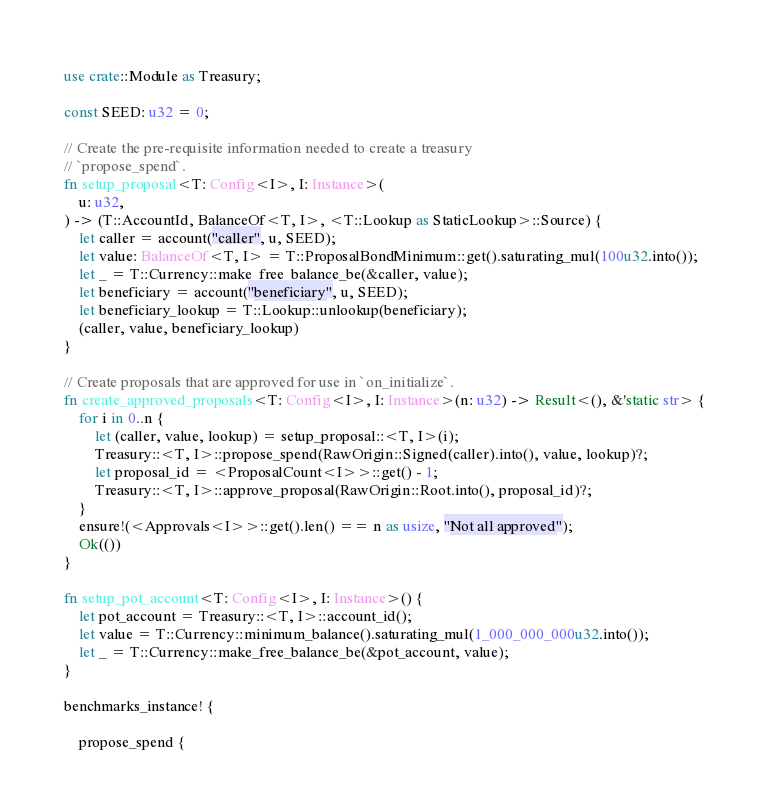Convert code to text. <code><loc_0><loc_0><loc_500><loc_500><_Rust_>
use crate::Module as Treasury;

const SEED: u32 = 0;

// Create the pre-requisite information needed to create a treasury
// `propose_spend`.
fn setup_proposal<T: Config<I>, I: Instance>(
	u: u32,
) -> (T::AccountId, BalanceOf<T, I>, <T::Lookup as StaticLookup>::Source) {
	let caller = account("caller", u, SEED);
	let value: BalanceOf<T, I> = T::ProposalBondMinimum::get().saturating_mul(100u32.into());
	let _ = T::Currency::make_free_balance_be(&caller, value);
	let beneficiary = account("beneficiary", u, SEED);
	let beneficiary_lookup = T::Lookup::unlookup(beneficiary);
	(caller, value, beneficiary_lookup)
}

// Create proposals that are approved for use in `on_initialize`.
fn create_approved_proposals<T: Config<I>, I: Instance>(n: u32) -> Result<(), &'static str> {
	for i in 0..n {
		let (caller, value, lookup) = setup_proposal::<T, I>(i);
		Treasury::<T, I>::propose_spend(RawOrigin::Signed(caller).into(), value, lookup)?;
		let proposal_id = <ProposalCount<I>>::get() - 1;
		Treasury::<T, I>::approve_proposal(RawOrigin::Root.into(), proposal_id)?;
	}
	ensure!(<Approvals<I>>::get().len() == n as usize, "Not all approved");
	Ok(())
}

fn setup_pot_account<T: Config<I>, I: Instance>() {
	let pot_account = Treasury::<T, I>::account_id();
	let value = T::Currency::minimum_balance().saturating_mul(1_000_000_000u32.into());
	let _ = T::Currency::make_free_balance_be(&pot_account, value);
}

benchmarks_instance! {

	propose_spend {</code> 